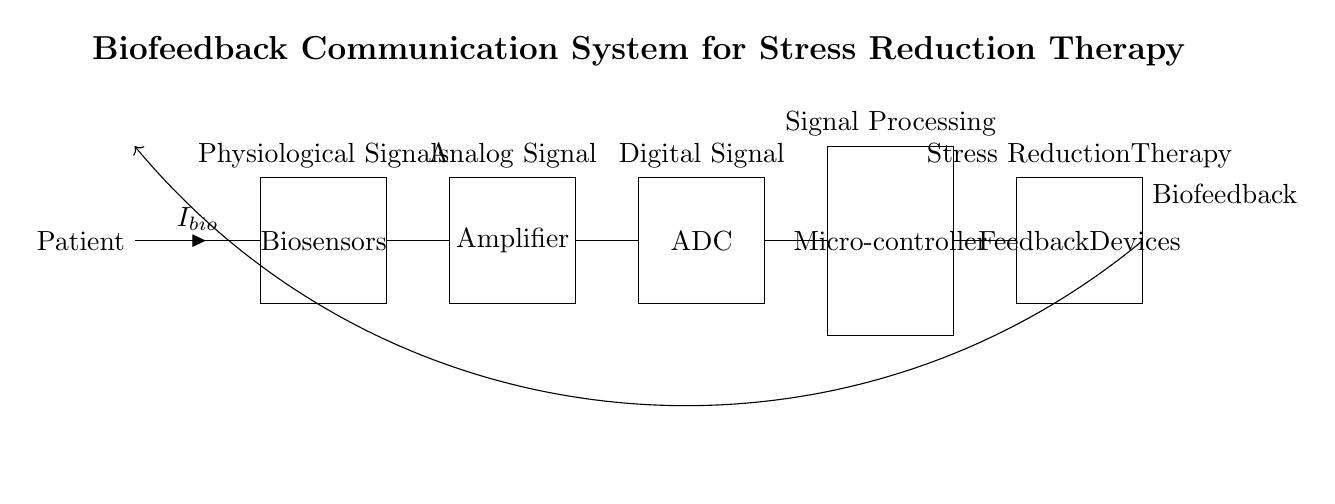What is the first component in the circuit? The first component in the circuit is the "Patient," represented by the label on the left. It indicates the start of the biofeedback system, as the physiological signals originate from the patient.
Answer: Patient What type of signal do the biosensors output? The biosensors output "Physiological Signals," which are depicted as originating from the patient and sent towards the amplifier. These signals represent the body’s responses relevant for therapy.
Answer: Physiological Signals What component comes after the amplification stage? The component that follows the amplification stage is the "ADC," or Analog to Digital Converter, which receives the analog signal from the amplifier for further processing.
Answer: ADC What is the role of the microcontroller in the circuit? The microcontroller's role is "Signal Processing," as it receives the digital signal from the ADC for analysis and control of the feedback mechanisms. This is essential for adapting therapy based on patient responses.
Answer: Signal Processing How are the feedback devices connected to the microcontroller? The feedback devices are connected to the microcontroller through a direct line, indicating that it sends processed signals directly to these devices for implementation in therapy.
Answer: Direct line What is the feedback loop's purpose in this circuit? The feedback loop's purpose is to enable "Biofeedback," allowing the response from the feedback devices to be sent back to the patient, creating an interactive system intended for stress reduction therapy.
Answer: Biofeedback 